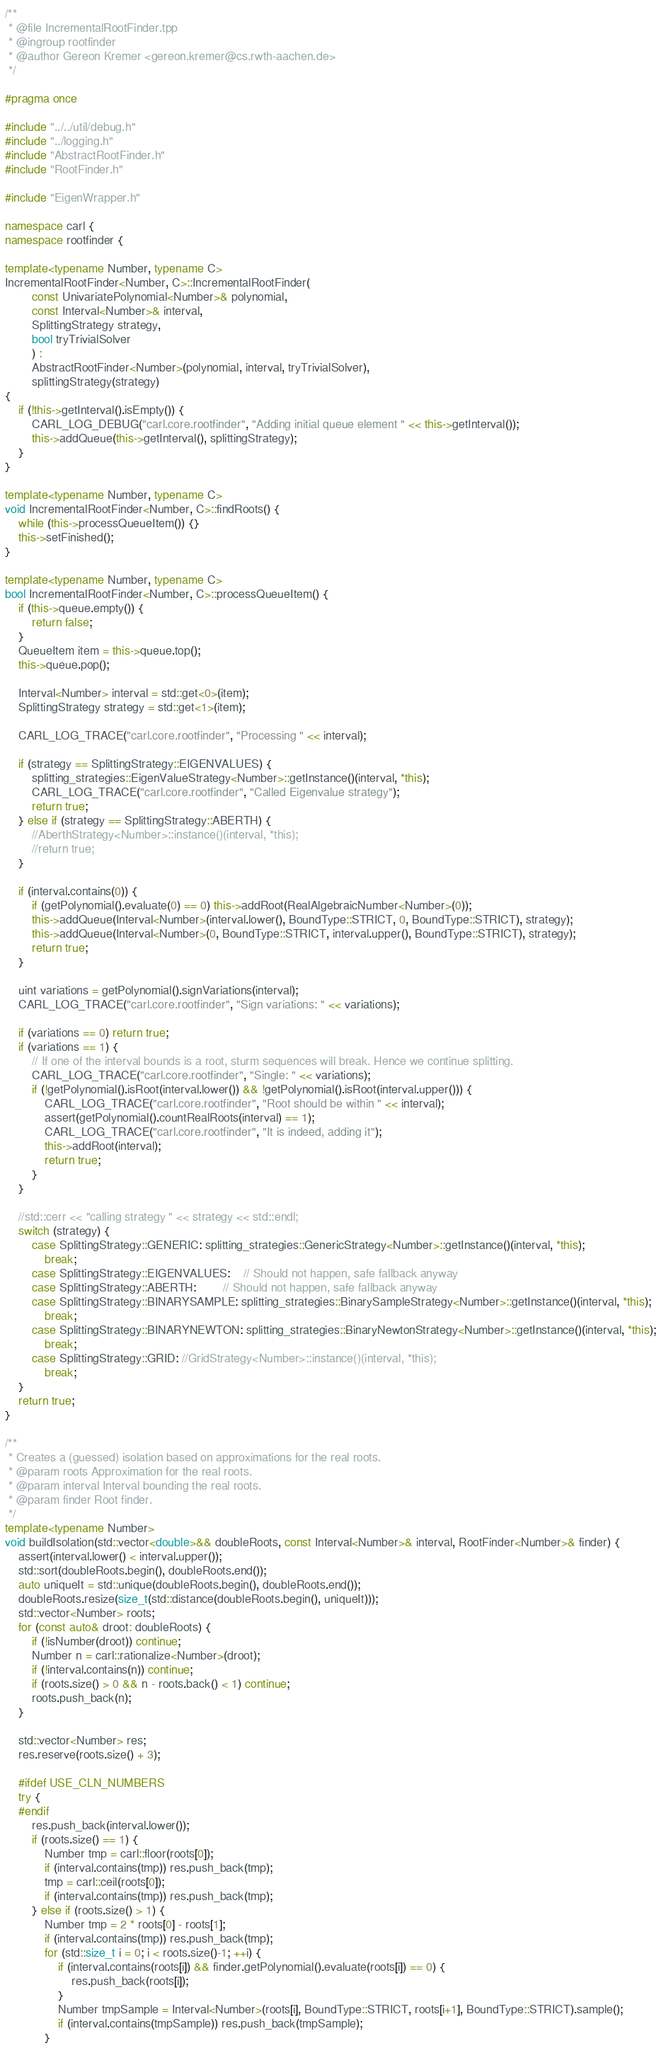<code> <loc_0><loc_0><loc_500><loc_500><_C++_>/**
 * @file IncrementalRootFinder.tpp
 * @ingroup rootfinder
 * @author Gereon Kremer <gereon.kremer@cs.rwth-aachen.de>
 */

#pragma once

#include "../../util/debug.h"
#include "../logging.h"
#include "AbstractRootFinder.h"
#include "RootFinder.h"

#include "EigenWrapper.h"

namespace carl {
namespace rootfinder {

template<typename Number, typename C>
IncrementalRootFinder<Number, C>::IncrementalRootFinder(
		const UnivariatePolynomial<Number>& polynomial,
		const Interval<Number>& interval,
		SplittingStrategy strategy,
		bool tryTrivialSolver
		) :
		AbstractRootFinder<Number>(polynomial, interval, tryTrivialSolver),
		splittingStrategy(strategy)
{
	if (!this->getInterval().isEmpty()) {
		CARL_LOG_DEBUG("carl.core.rootfinder", "Adding initial queue element " << this->getInterval());
		this->addQueue(this->getInterval(), splittingStrategy);
	}
}

template<typename Number, typename C>
void IncrementalRootFinder<Number, C>::findRoots() {
	while (this->processQueueItem()) {}
	this->setFinished();
}

template<typename Number, typename C>
bool IncrementalRootFinder<Number, C>::processQueueItem() {
	if (this->queue.empty()) {
		return false;
	}
	QueueItem item = this->queue.top();
	this->queue.pop();

	Interval<Number> interval = std::get<0>(item);
	SplittingStrategy strategy = std::get<1>(item);
	
	CARL_LOG_TRACE("carl.core.rootfinder", "Processing " << interval);

	if (strategy == SplittingStrategy::EIGENVALUES) {
		splitting_strategies::EigenValueStrategy<Number>::getInstance()(interval, *this);
		CARL_LOG_TRACE("carl.core.rootfinder", "Called Eigenvalue strategy");
		return true;
	} else if (strategy == SplittingStrategy::ABERTH) {
		//AberthStrategy<Number>::instance()(interval, *this);
		//return true;
	}

	if (interval.contains(0)) {
		if (getPolynomial().evaluate(0) == 0) this->addRoot(RealAlgebraicNumber<Number>(0));
		this->addQueue(Interval<Number>(interval.lower(), BoundType::STRICT, 0, BoundType::STRICT), strategy);
		this->addQueue(Interval<Number>(0, BoundType::STRICT, interval.upper(), BoundType::STRICT), strategy);
		return true;
	}

	uint variations = getPolynomial().signVariations(interval);
	CARL_LOG_TRACE("carl.core.rootfinder", "Sign variations: " << variations);

	if (variations == 0) return true;
	if (variations == 1) {
		// If one of the interval bounds is a root, sturm sequences will break. Hence we continue splitting.
		CARL_LOG_TRACE("carl.core.rootfinder", "Single: " << variations);
		if (!getPolynomial().isRoot(interval.lower()) && !getPolynomial().isRoot(interval.upper())) {
			CARL_LOG_TRACE("carl.core.rootfinder", "Root should be within " << interval);
			assert(getPolynomial().countRealRoots(interval) == 1);
			CARL_LOG_TRACE("carl.core.rootfinder", "It is indeed, adding it");
			this->addRoot(interval);
			return true;
		}
	}

	//std::cerr << "calling strategy " << strategy << std::endl;
	switch (strategy) {
		case SplittingStrategy::GENERIC: splitting_strategies::GenericStrategy<Number>::getInstance()(interval, *this);
			break;
		case SplittingStrategy::EIGENVALUES:	// Should not happen, safe fallback anyway
		case SplittingStrategy::ABERTH:		// Should not happen, safe fallback anyway
		case SplittingStrategy::BINARYSAMPLE: splitting_strategies::BinarySampleStrategy<Number>::getInstance()(interval, *this);
			break;
		case SplittingStrategy::BINARYNEWTON: splitting_strategies::BinaryNewtonStrategy<Number>::getInstance()(interval, *this);
			break;
		case SplittingStrategy::GRID: //GridStrategy<Number>::instance()(interval, *this);
			break;
	}
	return true;
}

/**
 * Creates a (guessed) isolation based on approximations for the real roots.
 * @param roots Approximation for the real roots.
 * @param interval Interval bounding the real roots.
 * @param finder Root finder.
 */
template<typename Number>
void buildIsolation(std::vector<double>&& doubleRoots, const Interval<Number>& interval, RootFinder<Number>& finder) {
	assert(interval.lower() < interval.upper());
	std::sort(doubleRoots.begin(), doubleRoots.end());
	auto uniqueIt = std::unique(doubleRoots.begin(), doubleRoots.end());
	doubleRoots.resize(size_t(std::distance(doubleRoots.begin(), uniqueIt)));
	std::vector<Number> roots;
	for (const auto& droot: doubleRoots) {
		if (!isNumber(droot)) continue;
		Number n = carl::rationalize<Number>(droot);
		if (!interval.contains(n)) continue;
		if (roots.size() > 0 && n - roots.back() < 1) continue;
		roots.push_back(n);
	}

	std::vector<Number> res;
	res.reserve(roots.size() + 3);
	
    #ifdef USE_CLN_NUMBERS
	try {
    #endif
		res.push_back(interval.lower());
		if (roots.size() == 1) {
			Number tmp = carl::floor(roots[0]);
			if (interval.contains(tmp)) res.push_back(tmp);
			tmp = carl::ceil(roots[0]);
			if (interval.contains(tmp)) res.push_back(tmp);
		} else if (roots.size() > 1) {
			Number tmp = 2 * roots[0] - roots[1];
			if (interval.contains(tmp)) res.push_back(tmp);
			for (std::size_t i = 0; i < roots.size()-1; ++i) {
				if (interval.contains(roots[i]) && finder.getPolynomial().evaluate(roots[i]) == 0) {
					res.push_back(roots[i]);
				}
				Number tmpSample = Interval<Number>(roots[i], BoundType::STRICT, roots[i+1], BoundType::STRICT).sample();
				if (interval.contains(tmpSample)) res.push_back(tmpSample);
			}</code> 